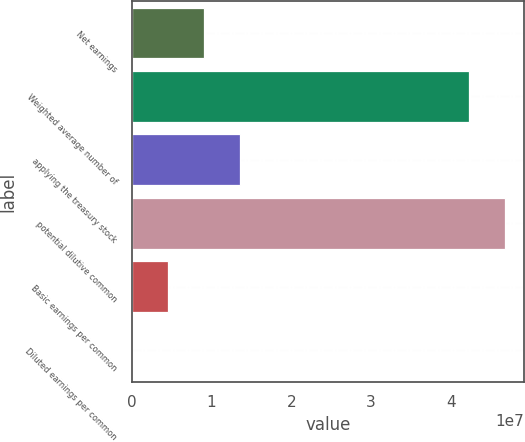Convert chart. <chart><loc_0><loc_0><loc_500><loc_500><bar_chart><fcel>Net earnings<fcel>Weighted average number of<fcel>applying the treasury stock<fcel>potential dilutive common<fcel>Basic earnings per common<fcel>Diluted earnings per common<nl><fcel>9.00553e+06<fcel>4.23125e+07<fcel>1.35083e+07<fcel>4.68153e+07<fcel>4.50276e+06<fcel>1.24<nl></chart> 